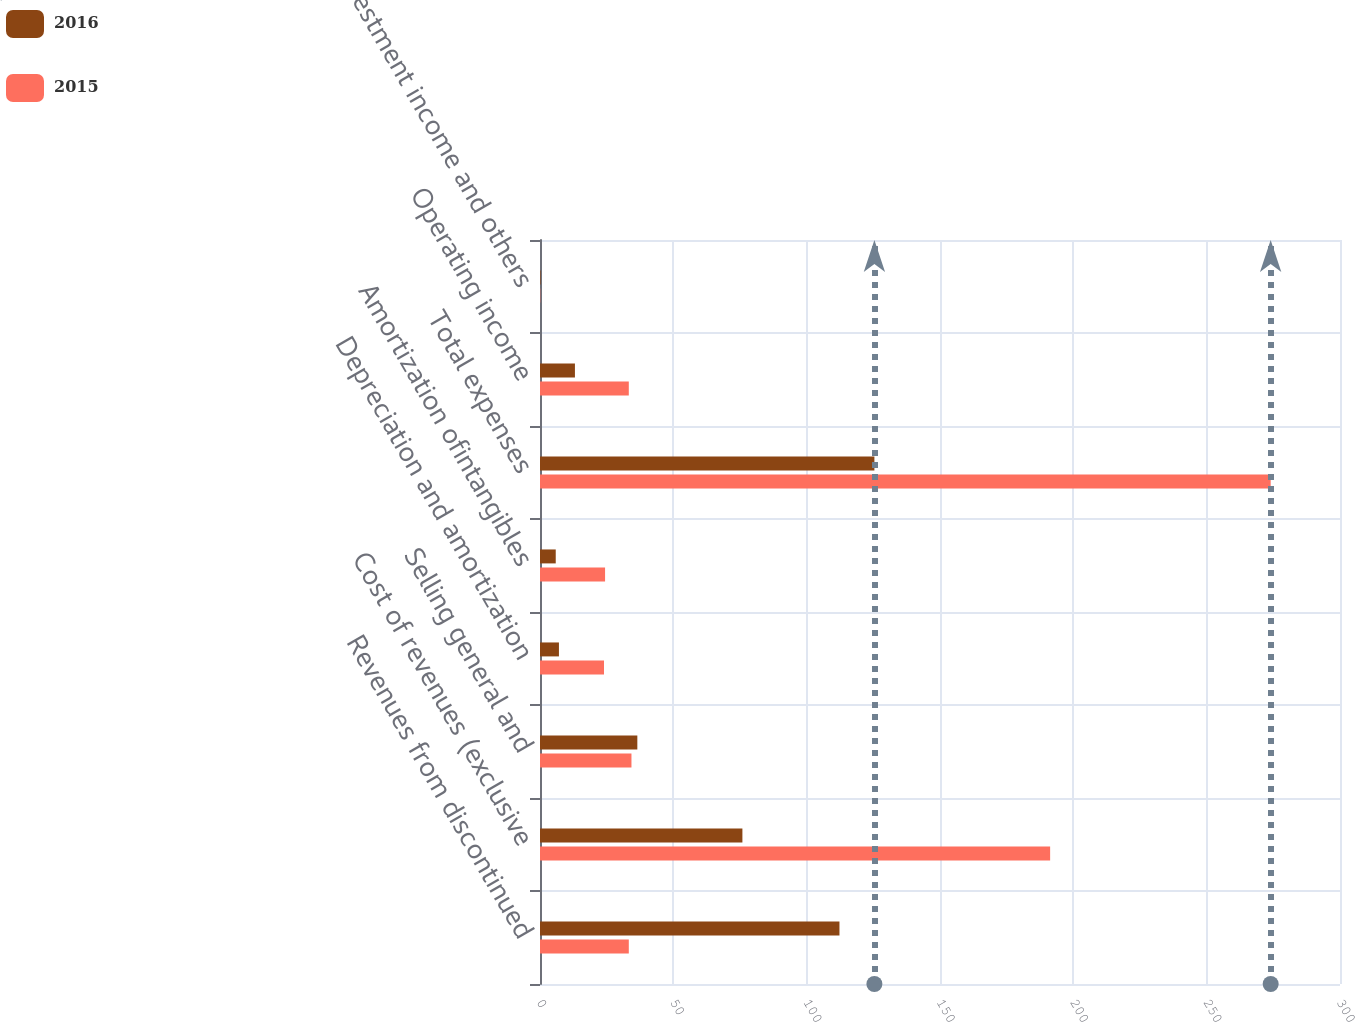Convert chart. <chart><loc_0><loc_0><loc_500><loc_500><stacked_bar_chart><ecel><fcel>Revenues from discontinued<fcel>Cost of revenues (exclusive<fcel>Selling general and<fcel>Depreciation and amortization<fcel>Amortization ofintangibles<fcel>Total expenses<fcel>Operating income<fcel>Investment income and others<nl><fcel>2016<fcel>112.3<fcel>75.9<fcel>36.5<fcel>7.1<fcel>5.9<fcel>125.4<fcel>13.1<fcel>0.2<nl><fcel>2015<fcel>33.3<fcel>191.3<fcel>34.3<fcel>24<fcel>24.4<fcel>274<fcel>33.3<fcel>0.1<nl></chart> 